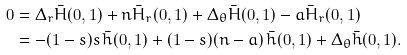Convert formula to latex. <formula><loc_0><loc_0><loc_500><loc_500>0 & = \Delta _ { r } \bar { H } ( 0 , 1 ) + n \bar { H } _ { r } ( 0 , 1 ) + \Delta _ { \theta } \bar { H } ( 0 , 1 ) - a \bar { H } _ { r } ( 0 , 1 ) \\ & = - ( 1 - s ) s \, \bar { h } ( 0 , 1 ) + ( 1 - s ) ( n - a ) \, \bar { h } ( 0 , 1 ) + \Delta _ { \theta } \bar { h } ( 0 , 1 ) .</formula> 